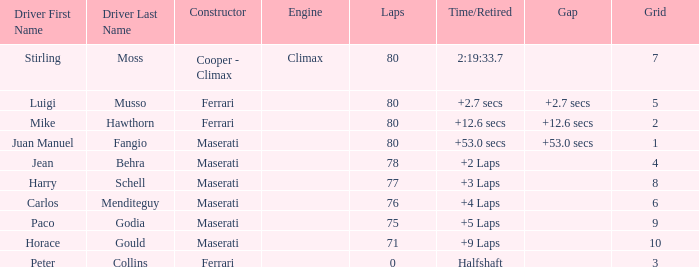What's the average Grid for a Maserati with less than 80 laps, and a Time/Retired of +2 laps? 4.0. 